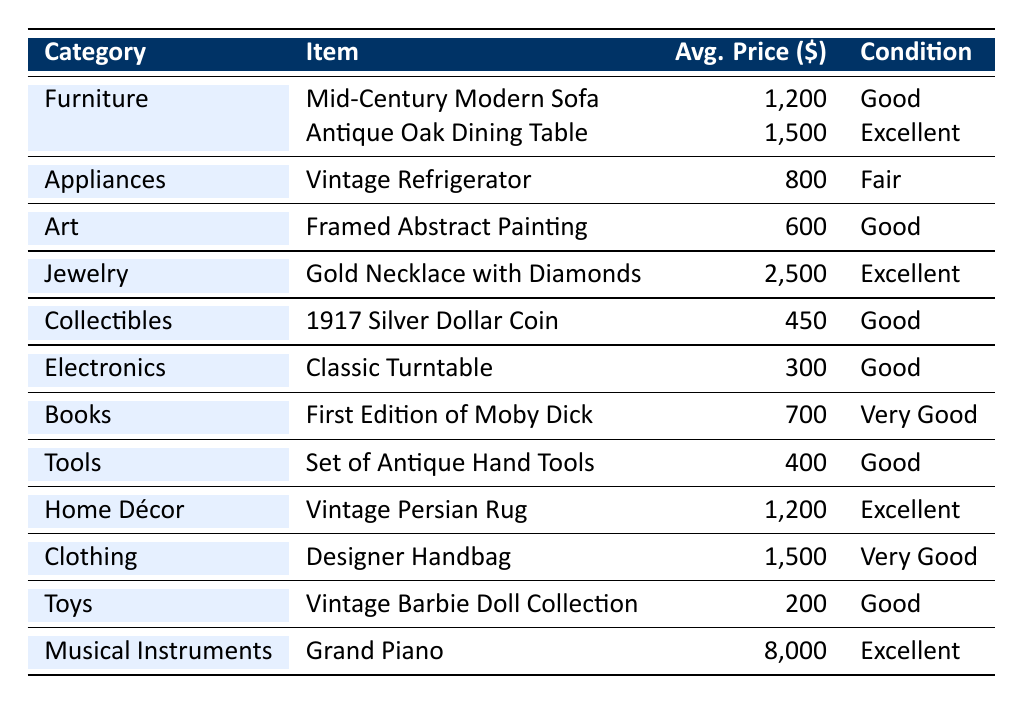What is the average sale price of furniture items? The average sale price for the furniture items (Mid-Century Modern Sofa for $1200 and Antique Oak Dining Table for $1500) is calculated by adding them together ($1200 + $1500 = $2700) and dividing by the number of items (2). Therefore, the average sale price is $2700 / 2 = $1350.
Answer: $1350 Which item has the highest average sale price? The highest average sale price in the table belongs to the Grand Piano, priced at $8000.
Answer: Grand Piano How many categories are listed in the table? There are 12 items divided into 9 unique categories: Furniture, Appliances, Art, Jewelry, Collectibles, Electronics, Books, Tools, Home Décor, Clothing, Toys, and Musical Instruments.
Answer: 12 unique categories Is there an item categorized as "Tools"? Yes, there is an item categorized as "Tools," which is the Set of Antique Hand Tools.
Answer: Yes What is the total average sale price of all items in the table? To find the total average sale price, we first sum up all the average sale prices of the items: $1200 + $1500 + $800 + $600 + $2500 + $450 + $300 + $700 + $400 + $1200 + $1500 + $200 + $8000 = $15,250. There are 12 items, so the total average sale price is $15,250 / 12 = approximately $1270.83.
Answer: Approximately $1270.83 Which category has the lowest average sale price? The category with the lowest average sale price is "Toys," specifically the Vintage Barbie Doll Collection, which averages at $200.
Answer: Toys Is there any item in "Jewelry" listed in "Good" condition? No, the only item in the "Jewelry" category (Gold Necklace with Diamonds) is listed as "Excellent" condition, not "Good."
Answer: No What is the condition of the Vintage Persian Rug? The Vintage Persian Rug is listed in "Excellent" condition.
Answer: Excellent How many items in total are in "Electronics"? There is 1 item listed in the "Electronics" category, which is the Classic Turntable.
Answer: 1 item What are the conditions of the items that have an average sale price over $1000? The items with average sale prices over $1000 are the Antique Oak Dining Table (Excellent), Gold Necklace with Diamonds (Excellent), and Grand Piano (Excellent). All these items are in "Excellent" condition.
Answer: Excellent Which categories have items priced between $600 and $800? The categories with items priced between $600 and $800 are "Art" (Framed Abstract Painting at $600) and "Appliances" (Vintage Refrigerator at $800).
Answer: Art and Appliances 